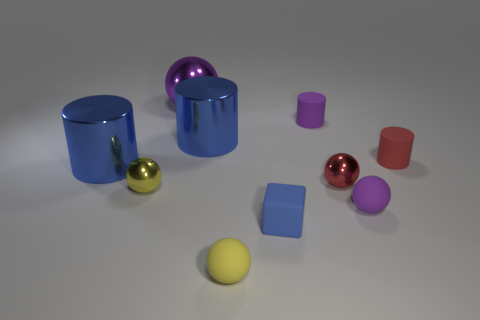How many large blue shiny objects are the same shape as the small red matte object?
Provide a succinct answer. 2. What number of small cubes are there?
Provide a short and direct response. 1. There is a large object that is on the left side of the yellow shiny ball; is its shape the same as the small yellow metal thing?
Give a very brief answer. No. There is a red cylinder that is the same size as the red shiny thing; what is it made of?
Your response must be concise. Rubber. Are there any tiny spheres that have the same material as the big purple object?
Ensure brevity in your answer.  Yes. There is a red metallic thing; is it the same shape as the rubber object left of the blue block?
Offer a terse response. Yes. How many spheres are behind the tiny yellow rubber ball and on the left side of the block?
Offer a terse response. 2. Are the big purple sphere and the small red thing behind the tiny red metallic object made of the same material?
Offer a terse response. No. Is the number of small red matte objects in front of the small yellow rubber sphere the same as the number of cubes?
Ensure brevity in your answer.  No. What color is the cylinder to the left of the large purple object?
Offer a very short reply. Blue. 